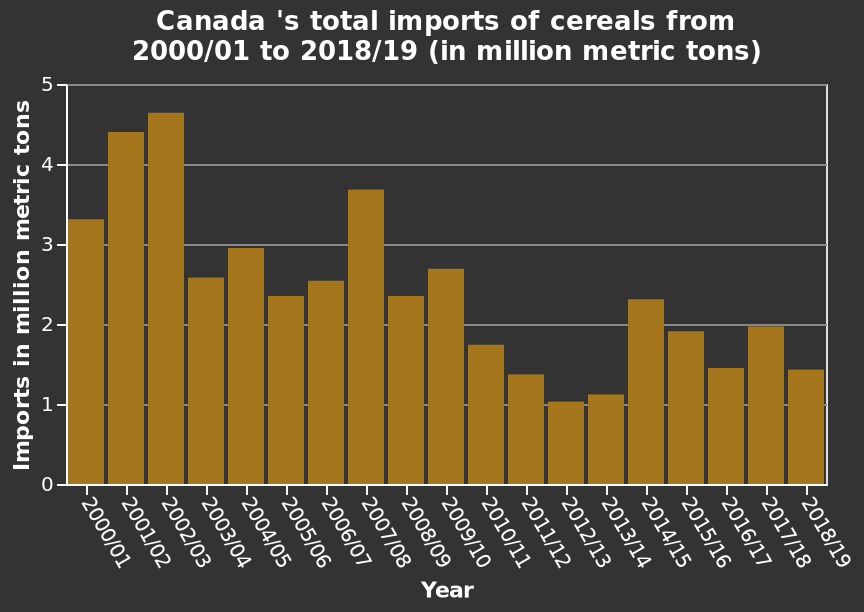<image>
What was the highest amount of cereals imported by Canada?  Canada imported the most cereals (close to 5 million metric tons) in 2002 / 2003. How is the data represented on the y-axis? The y-axis represents the imports of cereals in million metric tons. Over what time period does the bar plot show the imports? The bar plot shows the imports from 2000/01 to 2018/19. How much did Canada import in terms of cereals in 2012 / 2013? Canada imported just over 1 million metric tons of cereals in 2012 / 2013. 